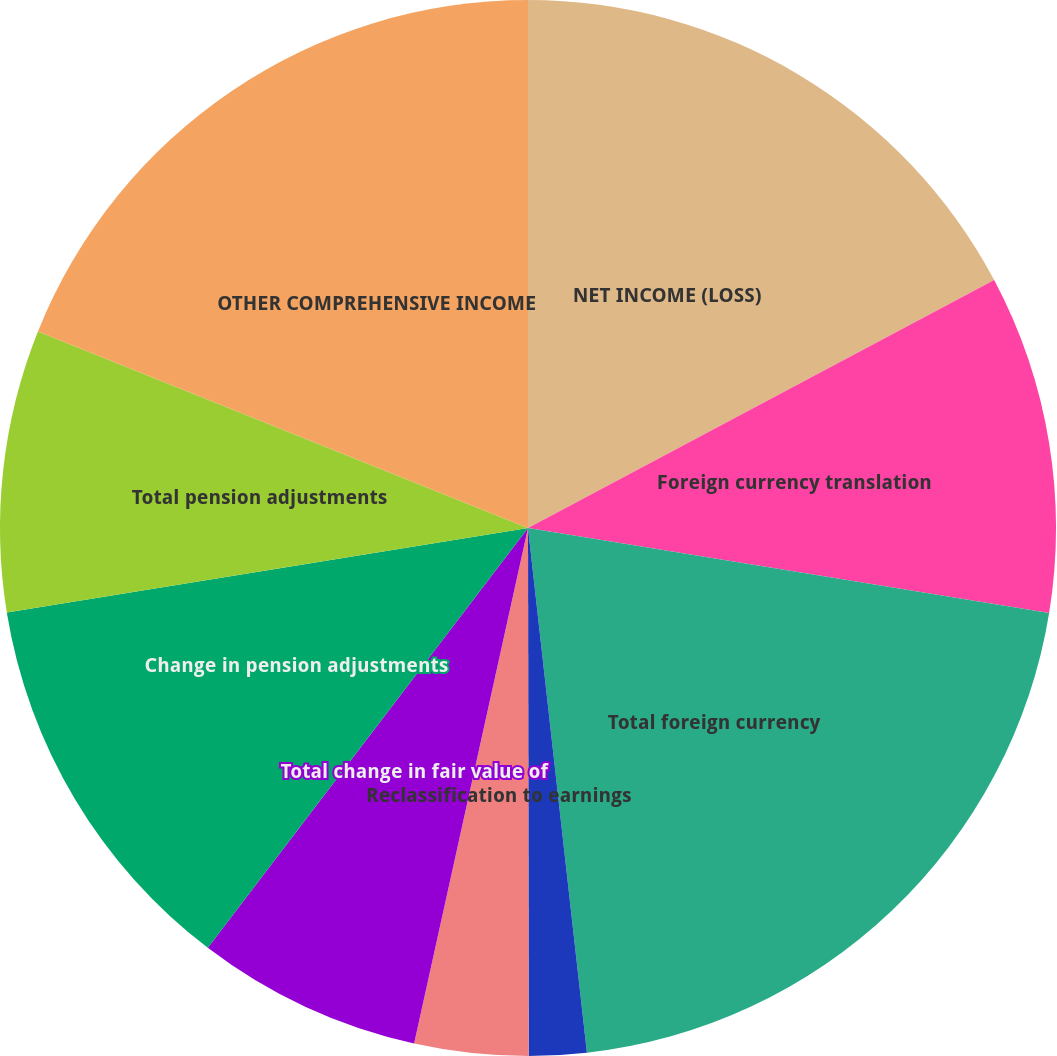Convert chart. <chart><loc_0><loc_0><loc_500><loc_500><pie_chart><fcel>NET INCOME (LOSS)<fcel>Foreign currency translation<fcel>Total foreign currency<fcel>Change in derivative fair<fcel>Reclassification to earnings<fcel>Total change in fair value of<fcel>Change in pension adjustments<fcel>Total pension adjustments<fcel>OTHER COMPREHENSIVE INCOME<nl><fcel>17.22%<fcel>10.35%<fcel>20.65%<fcel>1.76%<fcel>3.48%<fcel>6.91%<fcel>12.07%<fcel>8.63%<fcel>18.93%<nl></chart> 